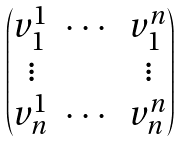<formula> <loc_0><loc_0><loc_500><loc_500>\begin{pmatrix} v _ { 1 } ^ { 1 } & \cdots & v _ { 1 } ^ { n } \\ \vdots & & \vdots \\ v _ { n } ^ { 1 } & \cdots & v _ { n } ^ { n } \end{pmatrix}</formula> 